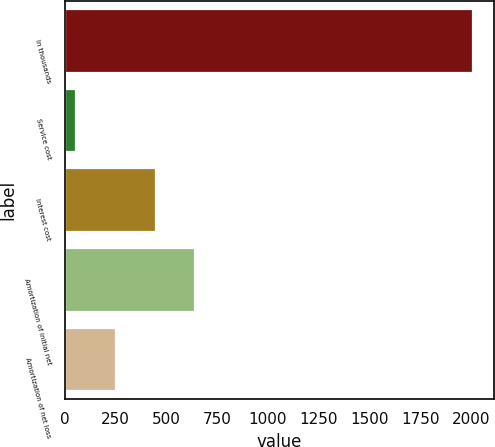<chart> <loc_0><loc_0><loc_500><loc_500><bar_chart><fcel>In thousands<fcel>Service cost<fcel>Interest cost<fcel>Amortization of initial net<fcel>Amortization of net loss<nl><fcel>2011<fcel>56<fcel>447<fcel>642.5<fcel>251.5<nl></chart> 